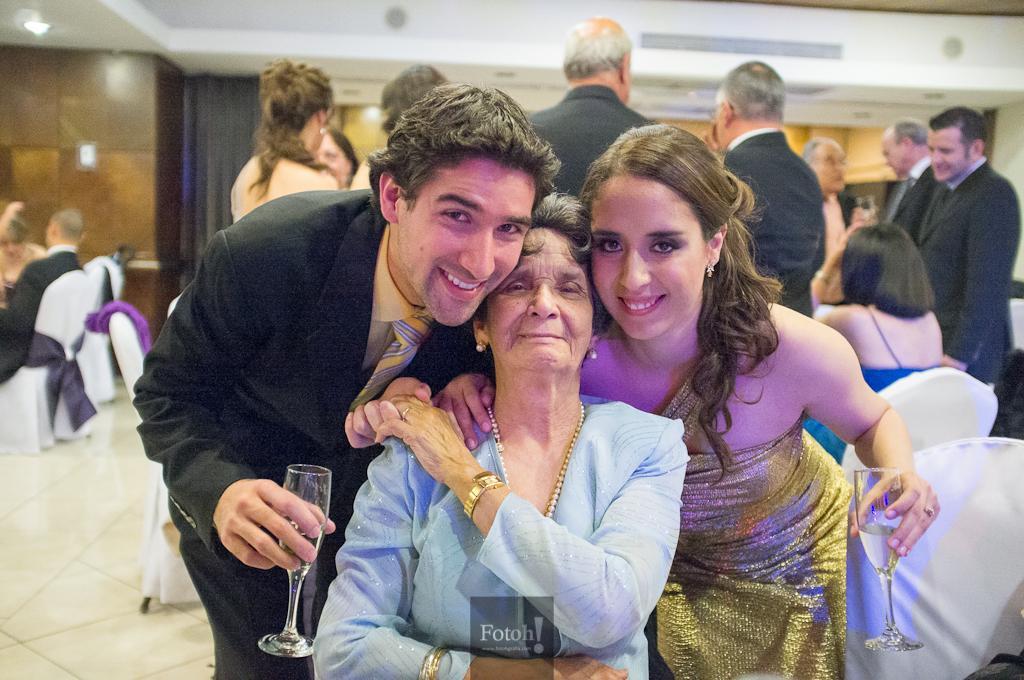Describe this image in one or two sentences. This picture shows a woman sitting in the chair on either side of a woman, there is a man and woman standing, holding glasses in their hands. In the background there are some people standing and sitting in the chairs. There is a wall and a curtain here. 